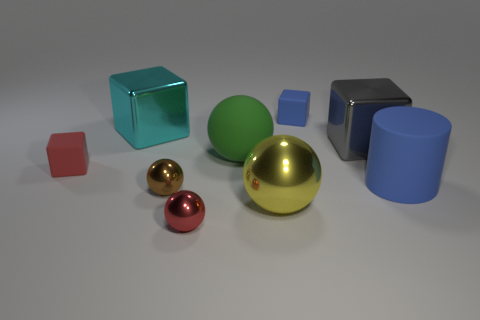How many objects have the same color as the big rubber cylinder?
Ensure brevity in your answer.  1. There is a tiny block that is the same color as the cylinder; what is it made of?
Keep it short and to the point. Rubber. What material is the cyan thing that is the same size as the blue cylinder?
Provide a succinct answer. Metal. What material is the large thing that is behind the big green matte sphere and to the left of the gray metal block?
Offer a very short reply. Metal. Is there a blue matte cube in front of the small rubber cube that is in front of the gray metallic block?
Provide a short and direct response. No. There is a block that is both in front of the cyan metallic object and left of the green matte sphere; how big is it?
Ensure brevity in your answer.  Small. What number of blue things are rubber objects or big rubber blocks?
Ensure brevity in your answer.  2. There is a gray object that is the same size as the matte ball; what is its shape?
Your response must be concise. Cube. What number of other objects are there of the same color as the big rubber sphere?
Your answer should be compact. 0. What is the size of the blue thing on the right side of the big metallic thing that is right of the tiny blue block?
Offer a terse response. Large. 